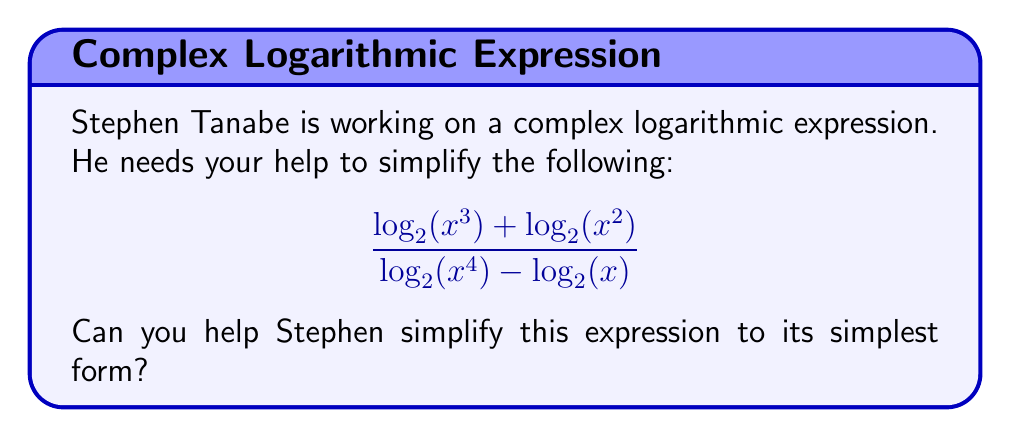Show me your answer to this math problem. Let's simplify this expression step by step:

1) First, let's use the properties of logarithms to simplify the numerator and denominator separately.

   Numerator: $\log_2(x^3) + \log_2(x^2) = \log_2(x^3 \cdot x^2) = \log_2(x^5)$

   Denominator: $\log_2(x^4) - \log_2(x) = \log_2(\frac{x^4}{x}) = \log_2(x^3)$

2) Now our expression looks like this:

   $$\frac{\log_2(x^5)}{\log_2(x^3)}$$

3) We can use the change of base formula to rewrite this in terms of natural logarithms:

   $$\frac{\frac{\ln(x^5)}{\ln(2)}}{\frac{\ln(x^3)}{\ln(2)}}$$

4) The $\ln(2)$ cancels out in the numerator and denominator:

   $$\frac{\ln(x^5)}{\ln(x^3)}$$

5) We can simplify the arguments of the logarithms:

   $$\frac{\ln(x^5)}{\ln(x^3)} = \frac{5\ln(x)}{3\ln(x)}$$

6) The $\ln(x)$ cancels out in the numerator and denominator:

   $$\frac{5}{3}$$

Thus, the complex rational expression simplifies to a simple fraction.
Answer: $\frac{5}{3}$ 